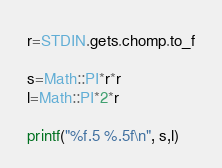Convert code to text. <code><loc_0><loc_0><loc_500><loc_500><_Ruby_>r=STDIN.gets.chomp.to_f

s=Math::PI*r*r
l=Math::PI*2*r

printf("%f.5 %.5f\n", s,l)</code> 